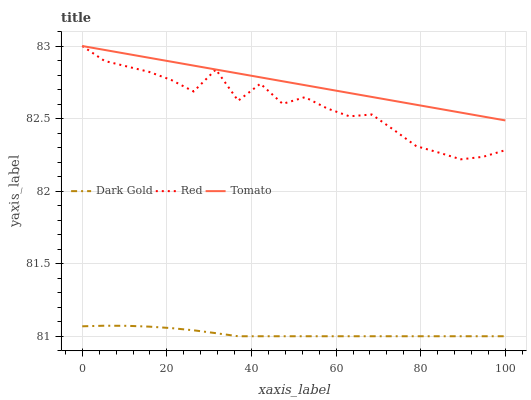Does Dark Gold have the minimum area under the curve?
Answer yes or no. Yes. Does Tomato have the maximum area under the curve?
Answer yes or no. Yes. Does Red have the minimum area under the curve?
Answer yes or no. No. Does Red have the maximum area under the curve?
Answer yes or no. No. Is Tomato the smoothest?
Answer yes or no. Yes. Is Red the roughest?
Answer yes or no. Yes. Is Dark Gold the smoothest?
Answer yes or no. No. Is Dark Gold the roughest?
Answer yes or no. No. Does Red have the lowest value?
Answer yes or no. No. Does Red have the highest value?
Answer yes or no. Yes. Does Dark Gold have the highest value?
Answer yes or no. No. Is Dark Gold less than Red?
Answer yes or no. Yes. Is Red greater than Dark Gold?
Answer yes or no. Yes. Does Dark Gold intersect Red?
Answer yes or no. No. 